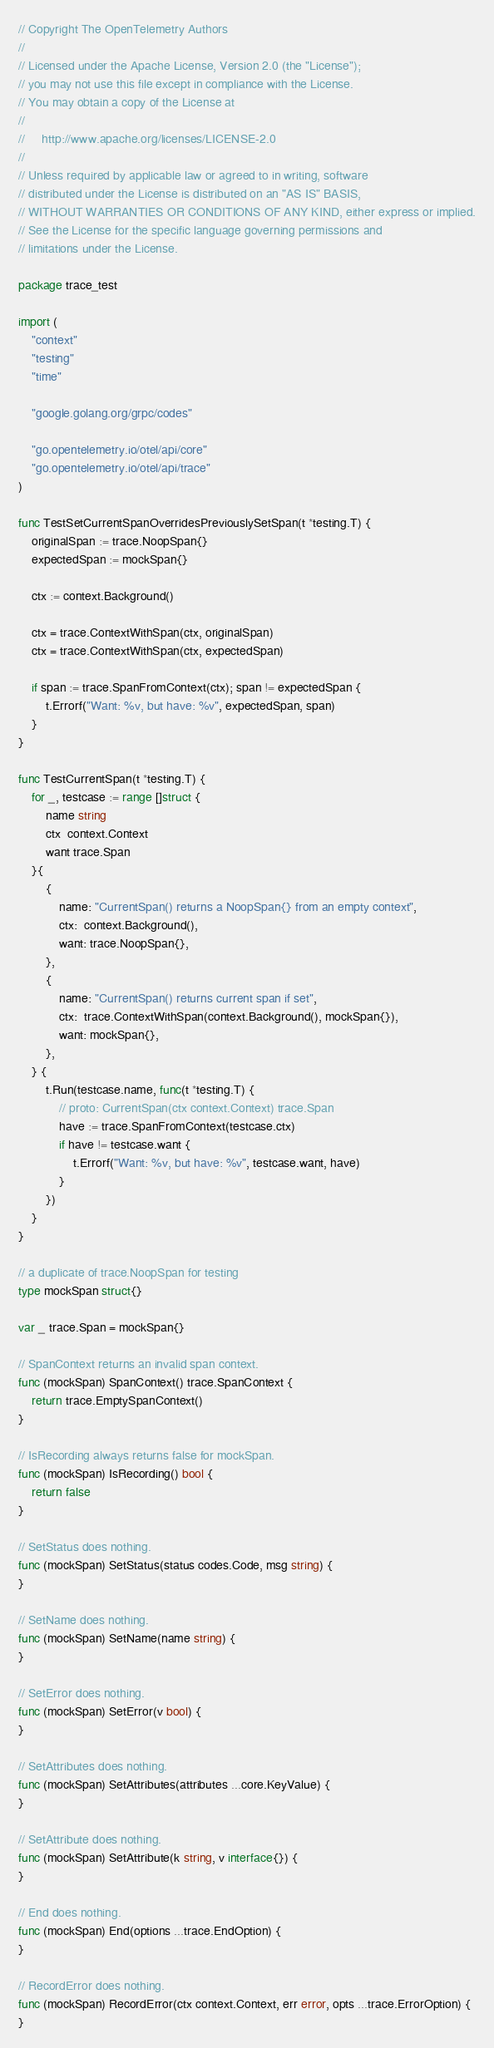Convert code to text. <code><loc_0><loc_0><loc_500><loc_500><_Go_>// Copyright The OpenTelemetry Authors
//
// Licensed under the Apache License, Version 2.0 (the "License");
// you may not use this file except in compliance with the License.
// You may obtain a copy of the License at
//
//     http://www.apache.org/licenses/LICENSE-2.0
//
// Unless required by applicable law or agreed to in writing, software
// distributed under the License is distributed on an "AS IS" BASIS,
// WITHOUT WARRANTIES OR CONDITIONS OF ANY KIND, either express or implied.
// See the License for the specific language governing permissions and
// limitations under the License.

package trace_test

import (
	"context"
	"testing"
	"time"

	"google.golang.org/grpc/codes"

	"go.opentelemetry.io/otel/api/core"
	"go.opentelemetry.io/otel/api/trace"
)

func TestSetCurrentSpanOverridesPreviouslySetSpan(t *testing.T) {
	originalSpan := trace.NoopSpan{}
	expectedSpan := mockSpan{}

	ctx := context.Background()

	ctx = trace.ContextWithSpan(ctx, originalSpan)
	ctx = trace.ContextWithSpan(ctx, expectedSpan)

	if span := trace.SpanFromContext(ctx); span != expectedSpan {
		t.Errorf("Want: %v, but have: %v", expectedSpan, span)
	}
}

func TestCurrentSpan(t *testing.T) {
	for _, testcase := range []struct {
		name string
		ctx  context.Context
		want trace.Span
	}{
		{
			name: "CurrentSpan() returns a NoopSpan{} from an empty context",
			ctx:  context.Background(),
			want: trace.NoopSpan{},
		},
		{
			name: "CurrentSpan() returns current span if set",
			ctx:  trace.ContextWithSpan(context.Background(), mockSpan{}),
			want: mockSpan{},
		},
	} {
		t.Run(testcase.name, func(t *testing.T) {
			// proto: CurrentSpan(ctx context.Context) trace.Span
			have := trace.SpanFromContext(testcase.ctx)
			if have != testcase.want {
				t.Errorf("Want: %v, but have: %v", testcase.want, have)
			}
		})
	}
}

// a duplicate of trace.NoopSpan for testing
type mockSpan struct{}

var _ trace.Span = mockSpan{}

// SpanContext returns an invalid span context.
func (mockSpan) SpanContext() trace.SpanContext {
	return trace.EmptySpanContext()
}

// IsRecording always returns false for mockSpan.
func (mockSpan) IsRecording() bool {
	return false
}

// SetStatus does nothing.
func (mockSpan) SetStatus(status codes.Code, msg string) {
}

// SetName does nothing.
func (mockSpan) SetName(name string) {
}

// SetError does nothing.
func (mockSpan) SetError(v bool) {
}

// SetAttributes does nothing.
func (mockSpan) SetAttributes(attributes ...core.KeyValue) {
}

// SetAttribute does nothing.
func (mockSpan) SetAttribute(k string, v interface{}) {
}

// End does nothing.
func (mockSpan) End(options ...trace.EndOption) {
}

// RecordError does nothing.
func (mockSpan) RecordError(ctx context.Context, err error, opts ...trace.ErrorOption) {
}
</code> 